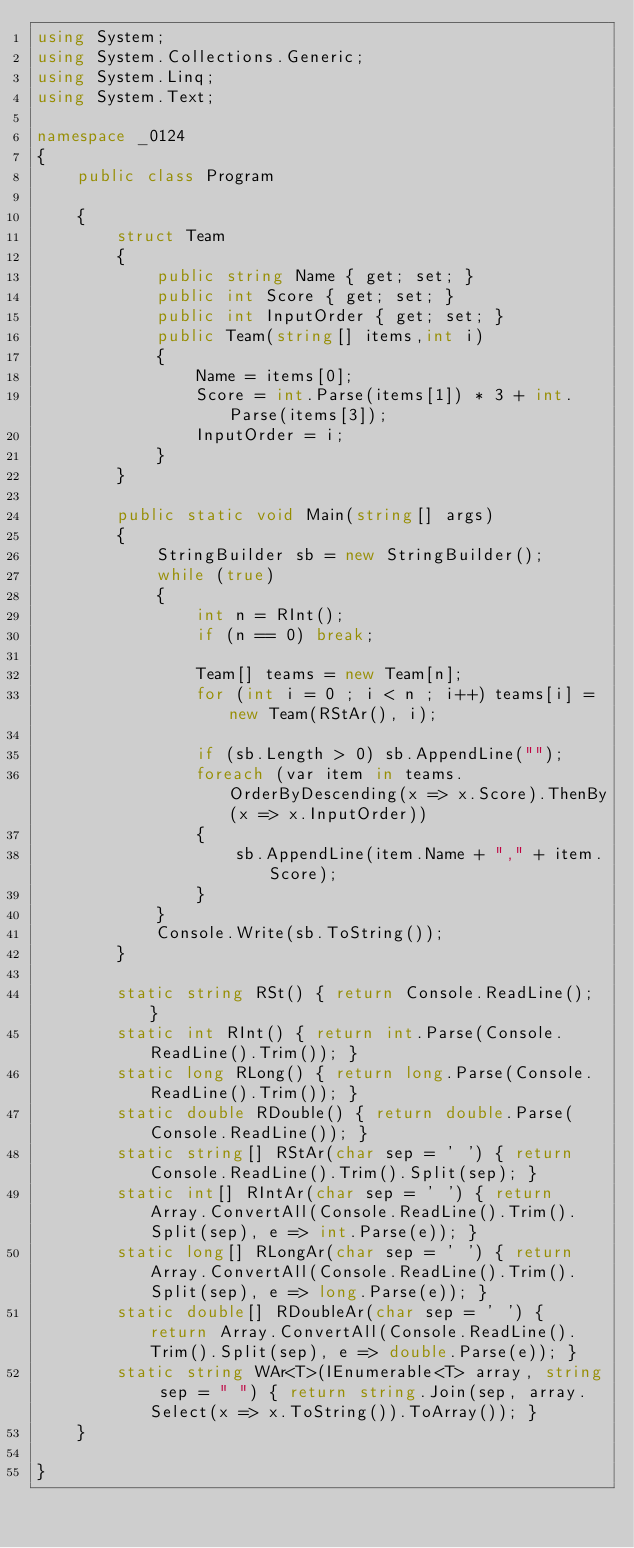<code> <loc_0><loc_0><loc_500><loc_500><_C#_>using System;
using System.Collections.Generic;
using System.Linq;
using System.Text;

namespace _0124
{
    public class Program

    {
        struct Team
        {
            public string Name { get; set; }
            public int Score { get; set; }
            public int InputOrder { get; set; }
            public Team(string[] items,int i)
            {
                Name = items[0];
                Score = int.Parse(items[1]) * 3 + int.Parse(items[3]);
                InputOrder = i;
            }
        }

        public static void Main(string[] args)
        {
            StringBuilder sb = new StringBuilder();
            while (true)
            {
                int n = RInt();
                if (n == 0) break;

                Team[] teams = new Team[n];
                for (int i = 0 ; i < n ; i++) teams[i] = new Team(RStAr(), i);

                if (sb.Length > 0) sb.AppendLine("");
                foreach (var item in teams.OrderByDescending(x => x.Score).ThenBy(x => x.InputOrder))
                {
                    sb.AppendLine(item.Name + "," + item.Score);
                }
            }
            Console.Write(sb.ToString());
        }

        static string RSt() { return Console.ReadLine(); }
        static int RInt() { return int.Parse(Console.ReadLine().Trim()); }
        static long RLong() { return long.Parse(Console.ReadLine().Trim()); }
        static double RDouble() { return double.Parse(Console.ReadLine()); }
        static string[] RStAr(char sep = ' ') { return Console.ReadLine().Trim().Split(sep); }
        static int[] RIntAr(char sep = ' ') { return Array.ConvertAll(Console.ReadLine().Trim().Split(sep), e => int.Parse(e)); }
        static long[] RLongAr(char sep = ' ') { return Array.ConvertAll(Console.ReadLine().Trim().Split(sep), e => long.Parse(e)); }
        static double[] RDoubleAr(char sep = ' ') { return Array.ConvertAll(Console.ReadLine().Trim().Split(sep), e => double.Parse(e)); }
        static string WAr<T>(IEnumerable<T> array, string sep = " ") { return string.Join(sep, array.Select(x => x.ToString()).ToArray()); }
    }

}

</code> 